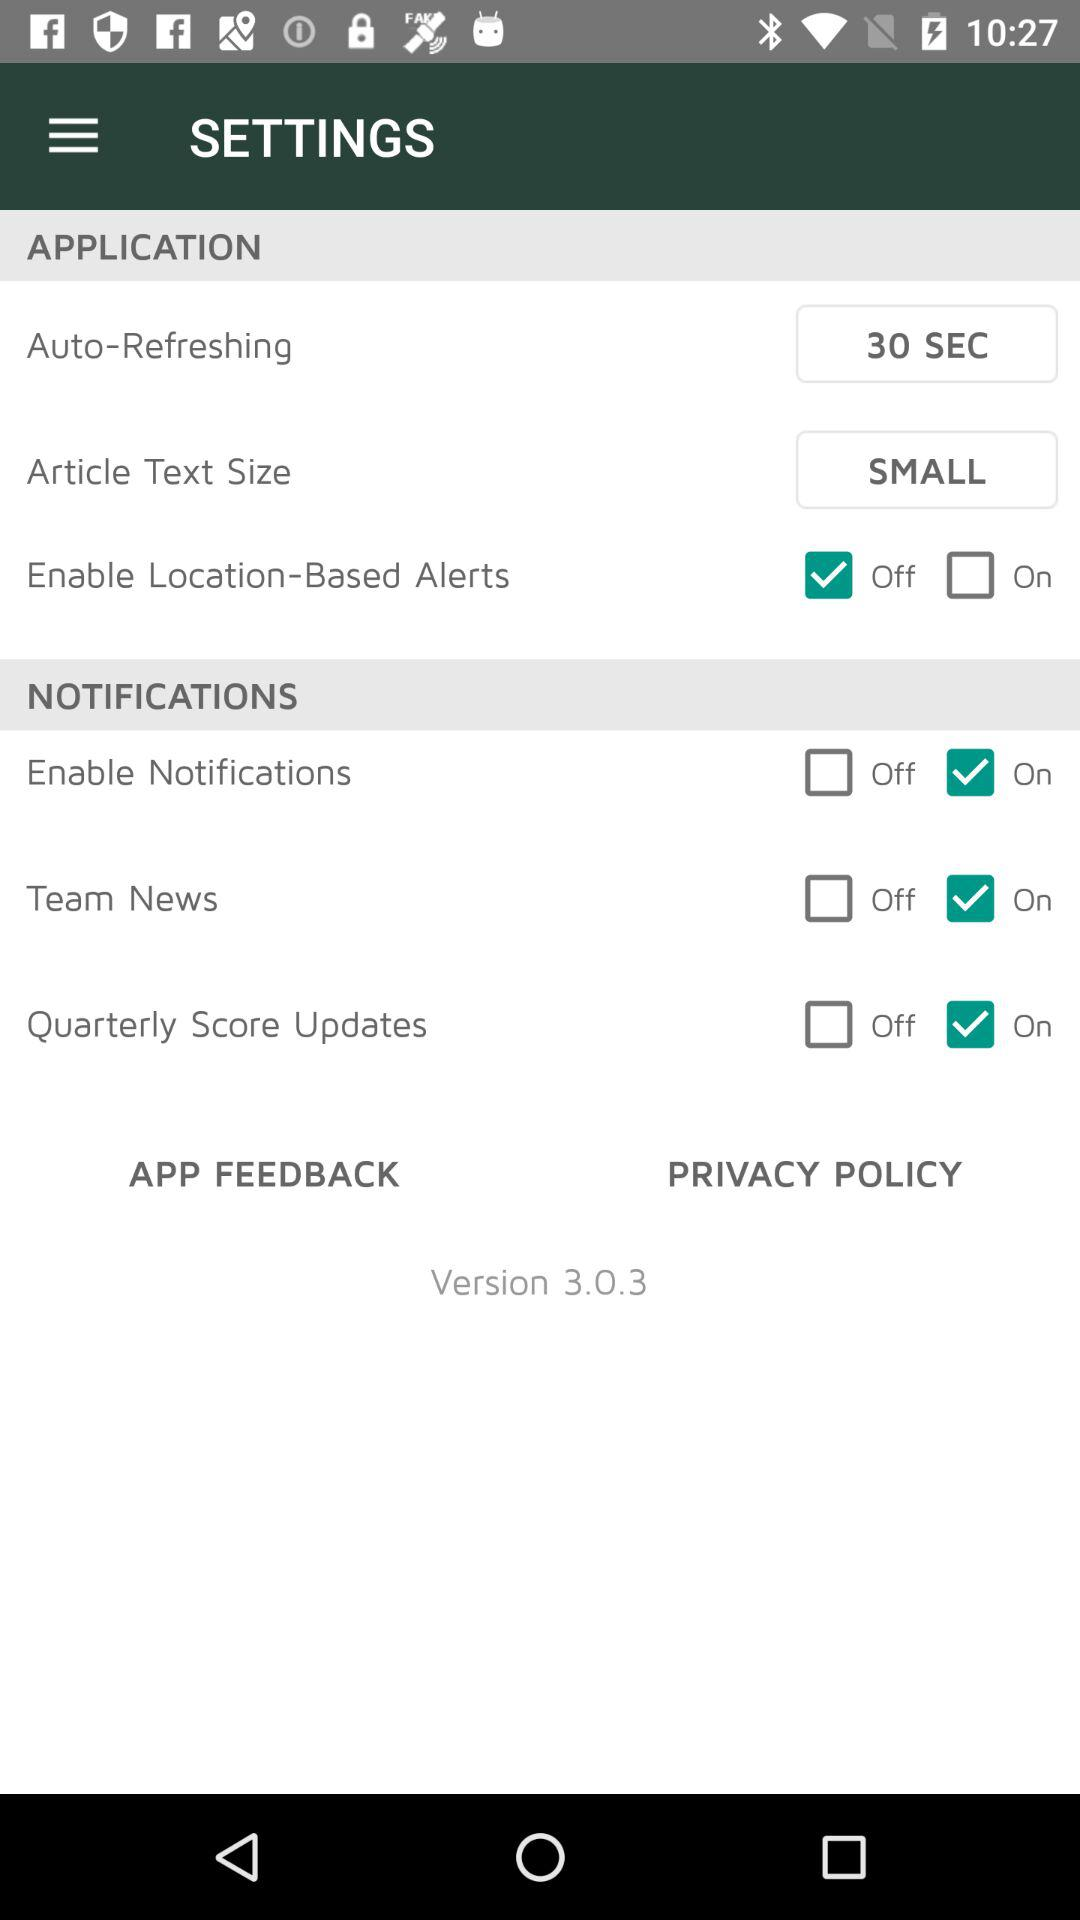Which notifications are "on"? The notifications that are "on" are "Enable Notifications", "Team News" and "Quarterly Score Updates". 